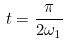Convert formula to latex. <formula><loc_0><loc_0><loc_500><loc_500>t = \frac { \pi } { 2 \omega _ { 1 } }</formula> 